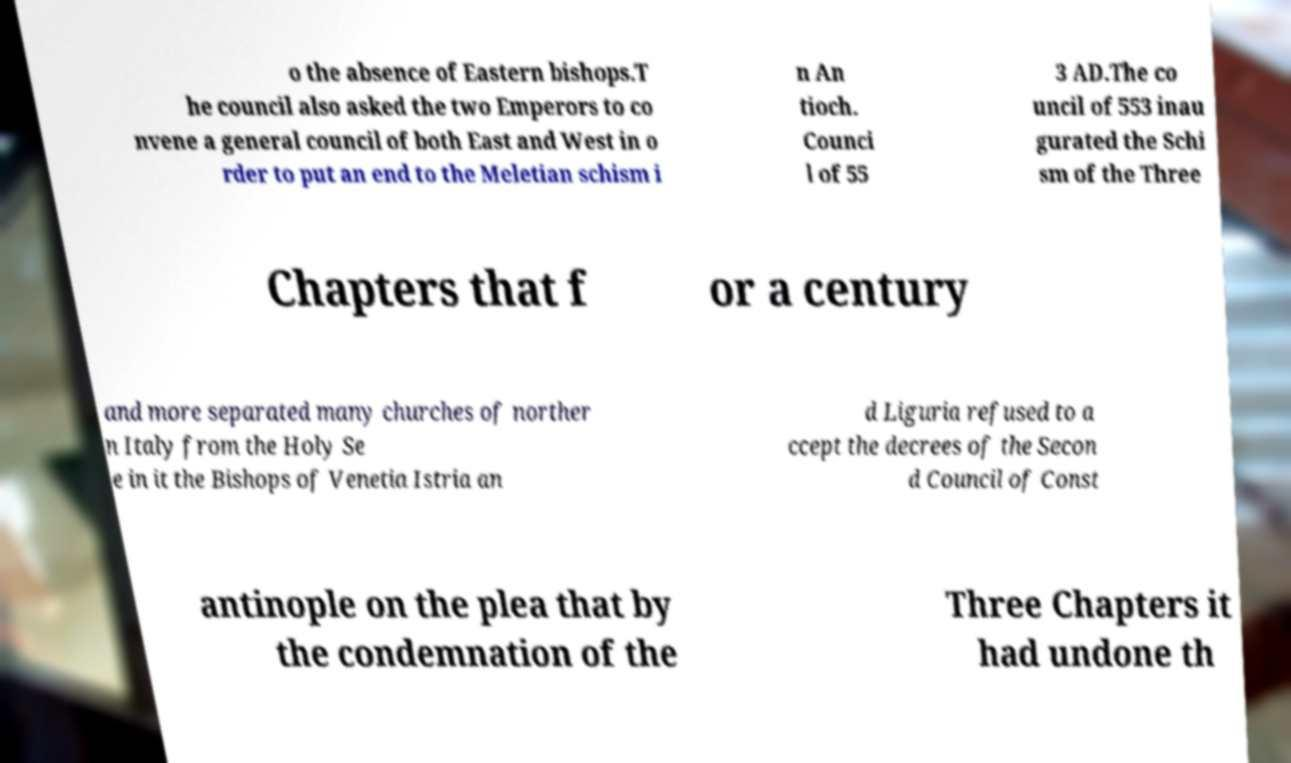Could you extract and type out the text from this image? o the absence of Eastern bishops.T he council also asked the two Emperors to co nvene a general council of both East and West in o rder to put an end to the Meletian schism i n An tioch. Counci l of 55 3 AD.The co uncil of 553 inau gurated the Schi sm of the Three Chapters that f or a century and more separated many churches of norther n Italy from the Holy Se e in it the Bishops of Venetia Istria an d Liguria refused to a ccept the decrees of the Secon d Council of Const antinople on the plea that by the condemnation of the Three Chapters it had undone th 